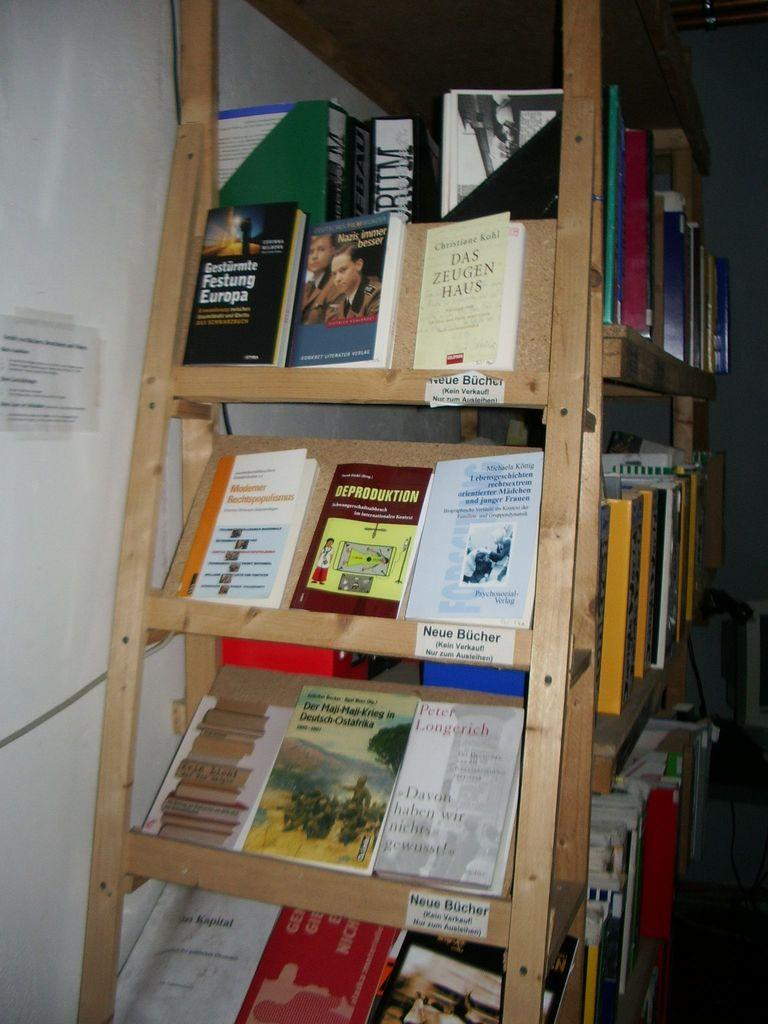Provide a one-sentence caption for the provided image. A group of German books at the end cap of a book shelf with a sign that reads Neue Bucher. 